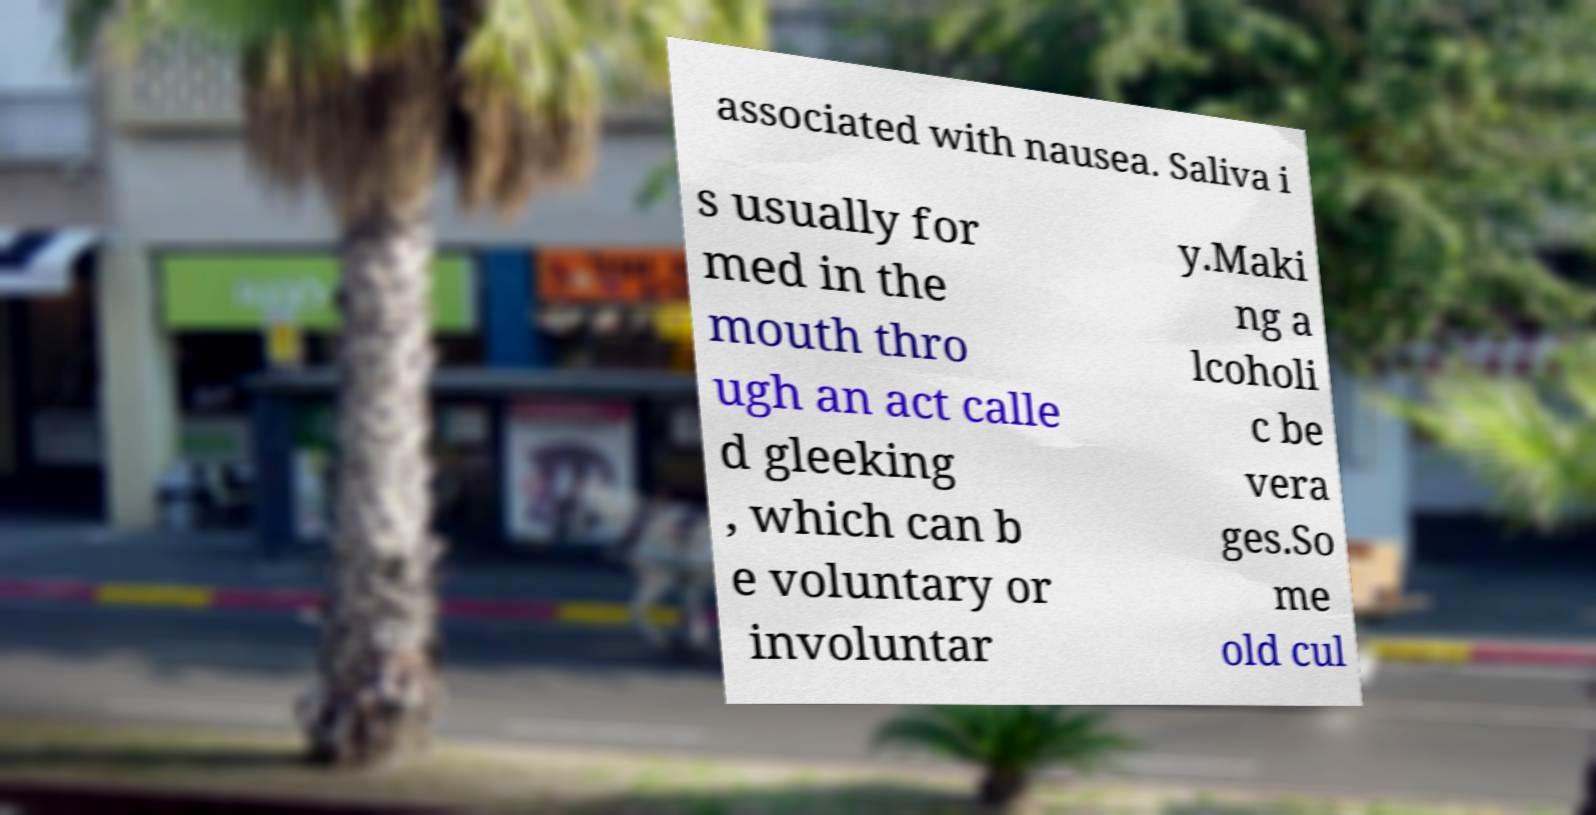Please identify and transcribe the text found in this image. associated with nausea. Saliva i s usually for med in the mouth thro ugh an act calle d gleeking , which can b e voluntary or involuntar y.Maki ng a lcoholi c be vera ges.So me old cul 